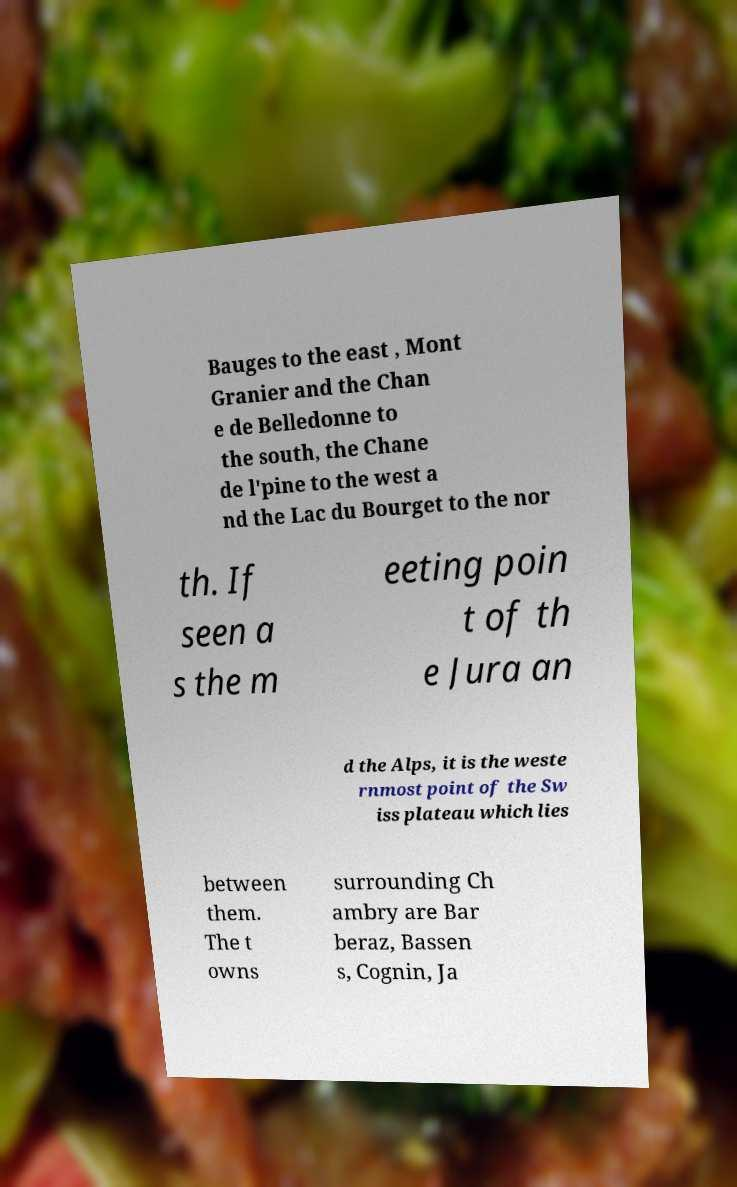Can you accurately transcribe the text from the provided image for me? Bauges to the east , Mont Granier and the Chan e de Belledonne to the south, the Chane de l'pine to the west a nd the Lac du Bourget to the nor th. If seen a s the m eeting poin t of th e Jura an d the Alps, it is the weste rnmost point of the Sw iss plateau which lies between them. The t owns surrounding Ch ambry are Bar beraz, Bassen s, Cognin, Ja 